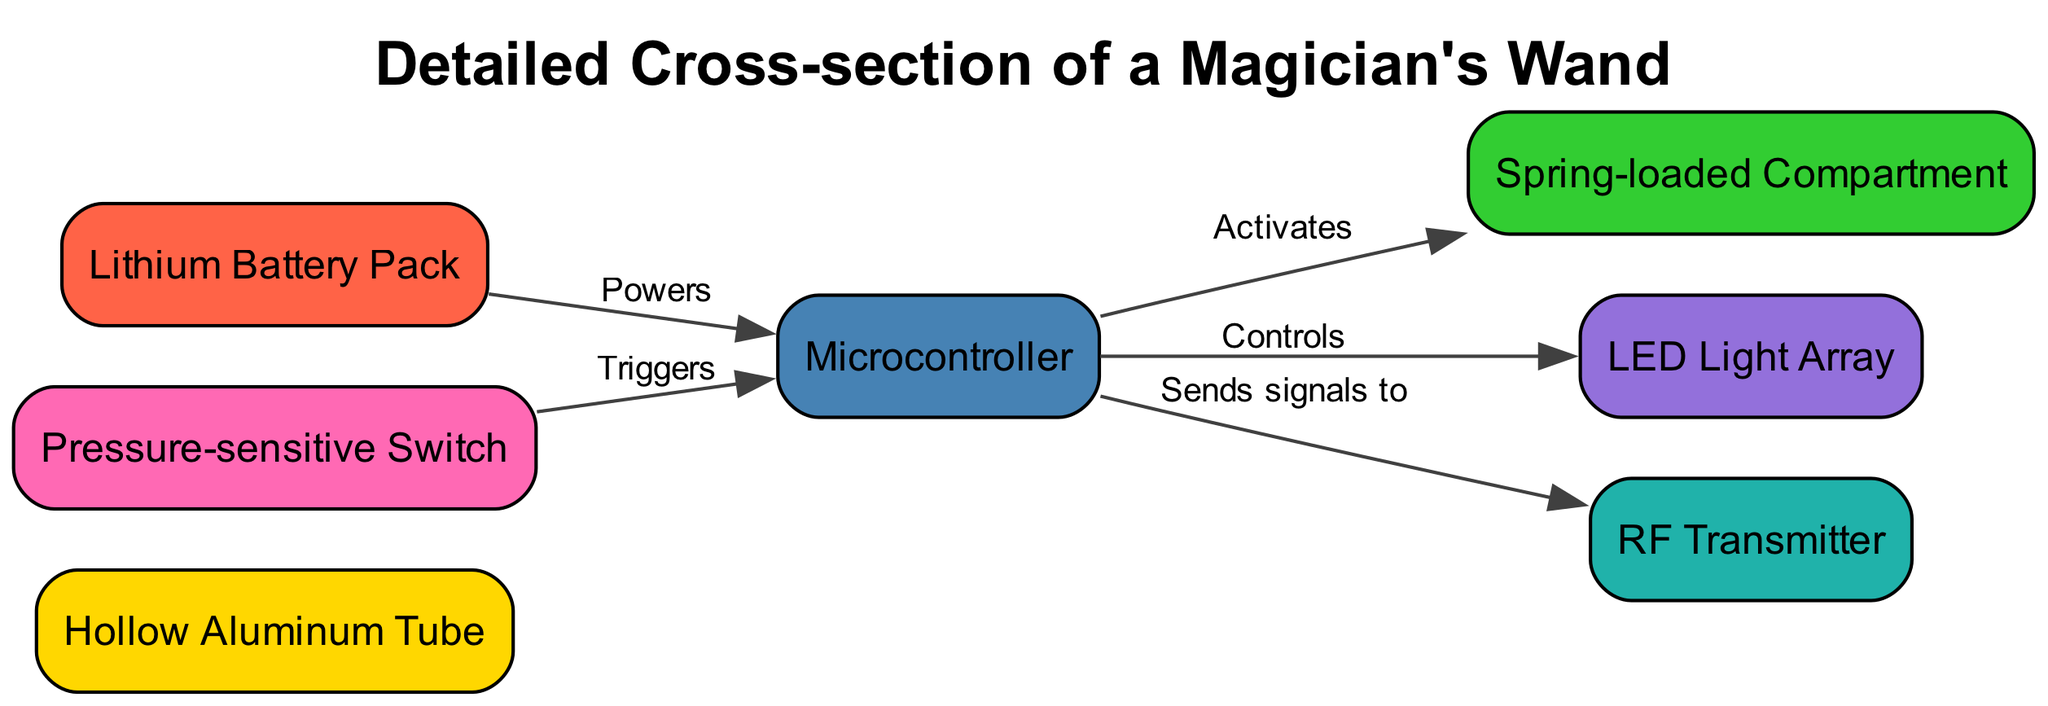What is the label of the first node? The first node listed in the data is "wand_body," which corresponds to the label "Hollow Aluminum Tube."
Answer: Hollow Aluminum Tube How many nodes are present in the diagram? The data indicates there are 7 nodes listed under "nodes" in the diagram, each representing a different component of the wand.
Answer: 7 What powers the control unit? The edge from "power_source" to "control_unit" is labeled "Powers," indicating that the Lithium Battery Pack powers the control unit.
Answer: Lithium Battery Pack Which mechanism is activated by the control unit? The edge from "control_unit" to "ejection_mechanism" is labeled "Activates," showing that the control unit activates the spring-loaded compartment.
Answer: Spring-loaded Compartment What triggers the control unit? The edge from "hidden_switch" to "control_unit" is labeled "Triggers," meaning the pressure-sensitive switch triggers the control unit.
Answer: Pressure-sensitive Switch What does the control unit send signals to? The edge from "control_unit" to "rf_transmitter" is labeled "Sends signals to," indicating that the control unit sends signals to the RF Transmitter.
Answer: RF Transmitter What is the relationship between the LED Light Array and the control unit? The edge from "control_unit" to "led_array" is labeled "Controls," showing that the control unit controls the LED Light Array.
Answer: Controls How many edges are in the diagram? The edges specify connections and interactions among the nodes, totaling 5 edges as listed under "edges" in the data.
Answer: 5 Which component is located at the center of the diagram? The control unit acts as a central component as it connects to multiple other nodes (ejection mechanism, LED array, RF transmitter, and hidden switch), making it the centerpiece.
Answer: Control Unit 